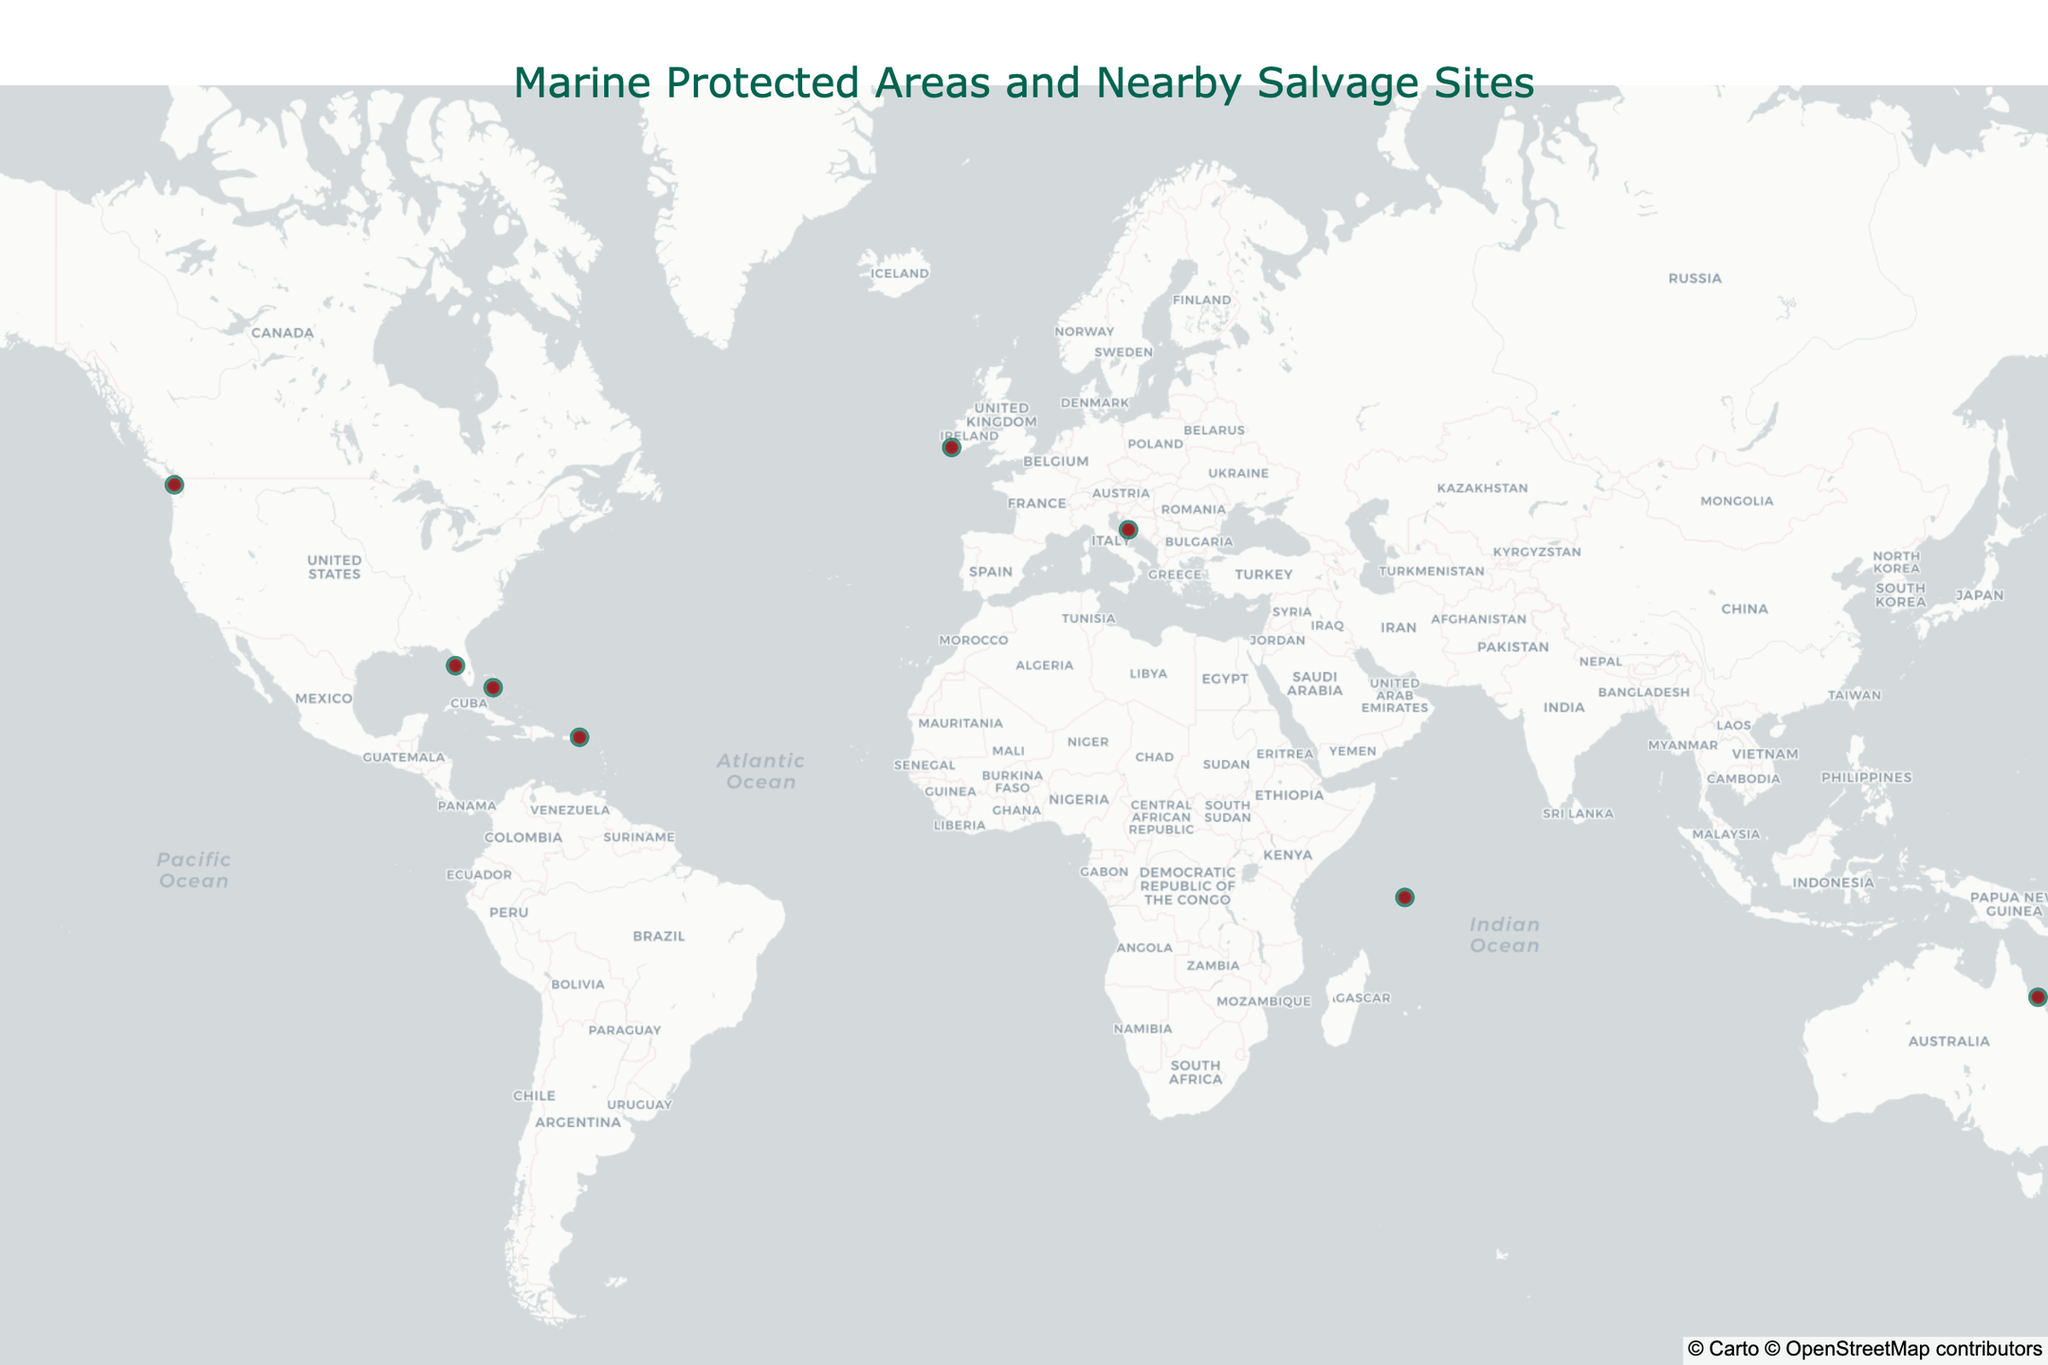How many Marine Protected Areas (MPAs) are displayed in the figure? Count the number of different MPAs marked on the map.
Answer: 10 What is the title of the figure? Read the title text at the top of the map.
Answer: Marine Protected Areas and Nearby Salvage Sites Which Marine Protected Area (MPA) is closest to a salvage site? Look at the distances in the hover data and identify the MPA with the smallest distance to its nearby salvage site.
Answer: Florida Keys National Marine Sanctuary Which salvage site is located closest to its Marine Protected Area (MPA)? Look at the distances in the hover data and identify the salvage site with the smallest distance.
Answer: USS Narcissus (1.9 km) What is the average distance between the MPAs and their nearby salvage sites? Sum all the distances and divide by the number of MPAs. (12.3 + 3.7 + 8.9 + 5.2 + 2.8 + 6.5 + 4.1 + 9.6 + 1.9 + 7.4) / 10 = 62.4 / 10
Answer: 6.24 km Which MPA has the furthest salvage site? Look at the distances and identify the MPA with the largest distance to its nearby salvage site.
Answer: Exuma Cays Land and Sea Park How many MPAs have salvage sites within 5 km? Count the number of MPAs with distances less than or equal to 5 km.
Answer: 4 What color marker represents the MPAs on the map? Observe the color of the larger markers used to denote MPAs.
Answer: Green What color marker represents the salvage sites on the map? Observe the color of the smaller markers used to denote salvage sites.
Answer: Red Which MPA is located near the coordinates (48.3854, -123.7392)? Match the given coordinates to the nearest MPA on the map using the hover data.
Answer: Race Rocks Ecological Reserve 